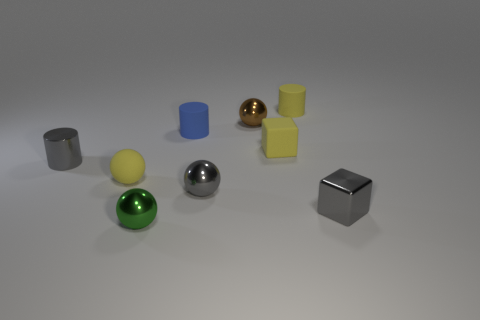Are there more small shiny spheres that are in front of the brown ball than small green metal objects?
Offer a terse response. Yes. There is a matte thing left of the green object; does it have the same shape as the blue object?
Your response must be concise. No. What number of things are either big gray objects or small things that are in front of the small yellow matte cylinder?
Provide a succinct answer. 8. What is the size of the thing that is both right of the brown metal ball and behind the blue rubber thing?
Your answer should be very brief. Small. Are there more yellow matte things that are behind the tiny gray cylinder than tiny objects on the left side of the small matte ball?
Give a very brief answer. Yes. There is a small blue object; does it have the same shape as the gray thing on the left side of the tiny green object?
Your response must be concise. Yes. How many other things are there of the same shape as the small brown shiny object?
Provide a succinct answer. 3. There is a tiny metal thing that is both to the right of the gray cylinder and left of the tiny blue rubber object; what color is it?
Provide a short and direct response. Green. What color is the metallic cylinder?
Your answer should be very brief. Gray. Is the material of the gray cylinder the same as the small block that is in front of the yellow rubber sphere?
Offer a terse response. Yes. 